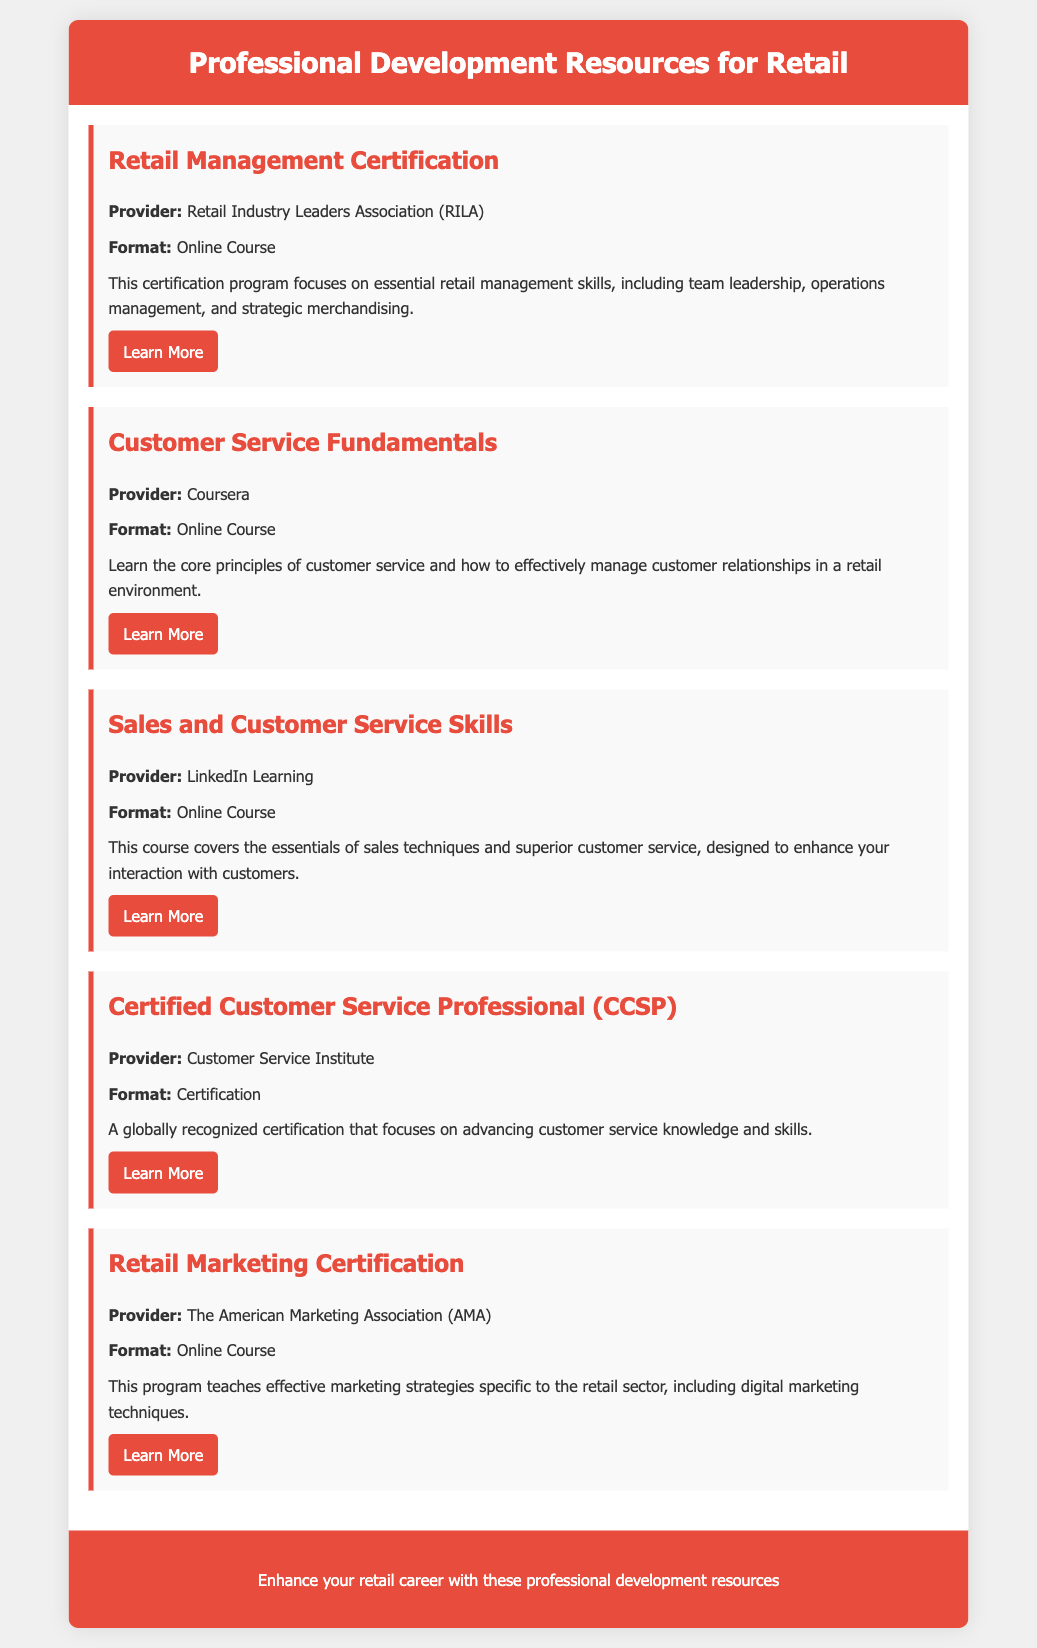what is the title of the document? The title is found in the header section of the document.
Answer: Professional Development Resources for Retail who provides the Retail Management Certification? The provider name is mentioned in the resource description.
Answer: Retail Industry Leaders Association (RILA) which course focuses on customer relationships? The course focusing on customer relationships is specified in the course description.
Answer: Customer Service Fundamentals how many online courses are listed in the document? The total number of online courses can be counted from the resources section.
Answer: 4 what certification is globally recognized? The certification is highlighted in the resource description.
Answer: Certified Customer Service Professional (CCSP) which provider offers the Retail Marketing Certification? The provider is stated directly in the resource description.
Answer: The American Marketing Association (AMA) what is the format of the Sales and Customer Service Skills course? The format is specified in each resource's description.
Answer: Online Course what skills does the Retail Management Certification focus on? The skills are mentioned in the course description.
Answer: Essential retail management skills 